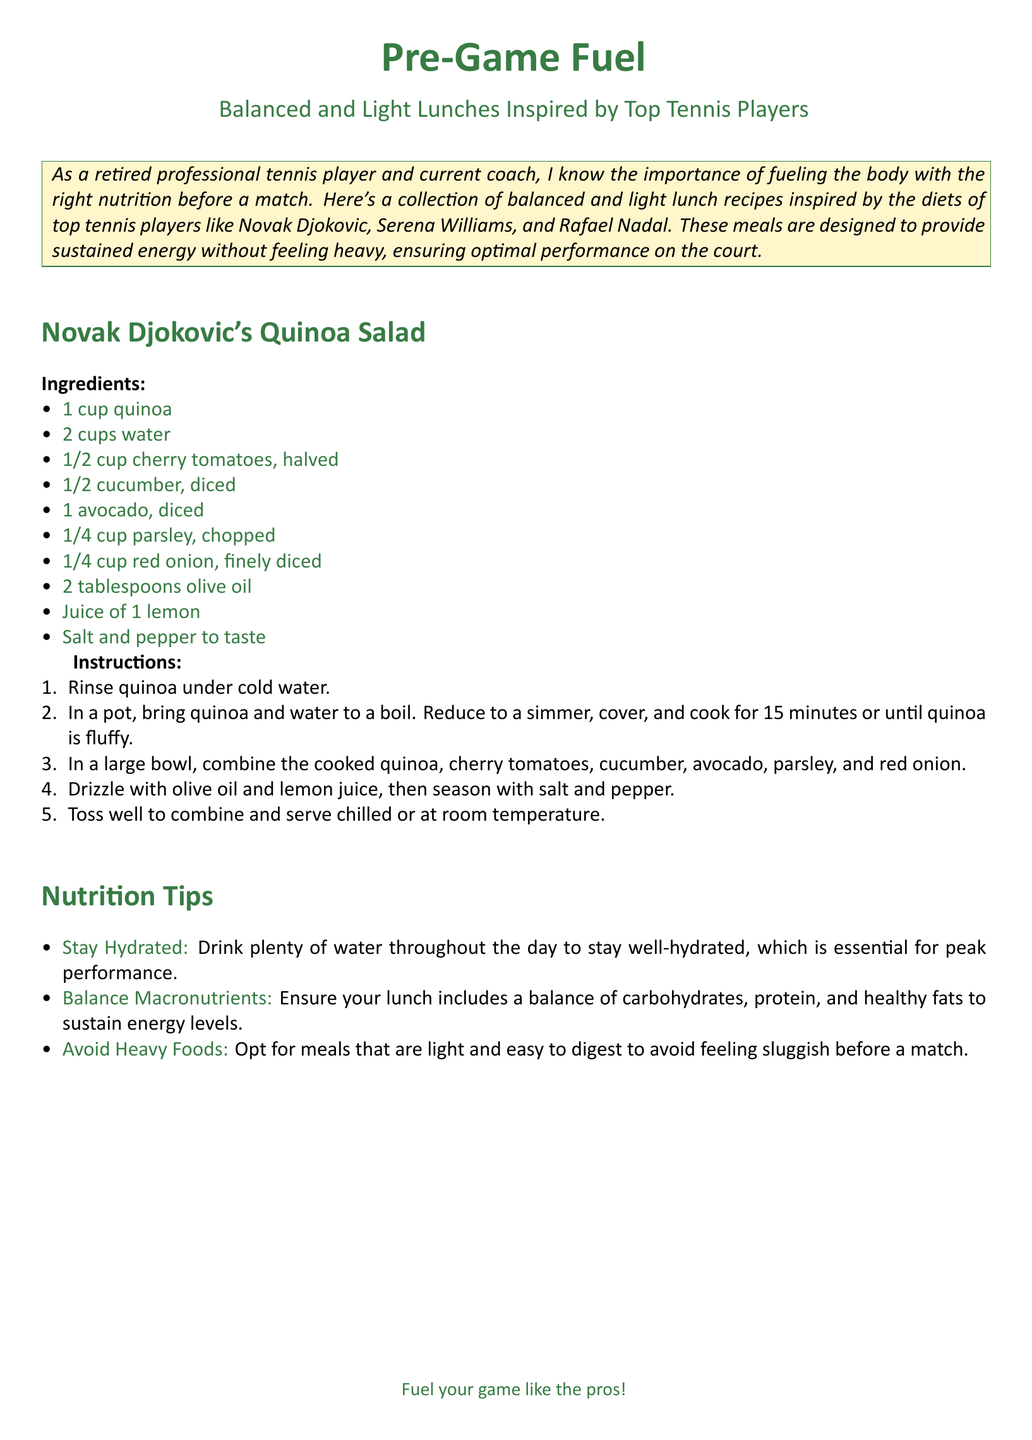What is the title of the document? The title of the document is centered at the top and states "Pre-Game Fuel".
Answer: Pre-Game Fuel Who is the inspiration behind the recipes? The text mentions that the recipes are inspired by top tennis players, including names like Novak Djokovic and Serena Williams.
Answer: Top tennis players How many cups of quinoa are needed for the salad? The ingredients list states that 1 cup of quinoa is required.
Answer: 1 cup What type of oil is used in the quinoa salad? The ingredients list includes 2 tablespoons of olive oil.
Answer: Olive oil What is the cooking time for the quinoa? The instructions specify that the quinoa should be cooked for 15 minutes.
Answer: 15 minutes What is a key nutrition tip mentioned in the document? The document provides several nutrition tips, one of which emphasizes staying hydrated.
Answer: Stay Hydrated How is the quinoa salad served? The instructions indicate that the salad can be served chilled or at room temperature.
Answer: Chilled or room temperature What is the main purpose of the document? The text introduces the collection of recipes as a way to fuel the body with proper nutrition before matches.
Answer: Fueling the body What is one of the ingredients in the salad besides quinoa? The ingredients list includes other components, such as cherry tomatoes or avocado.
Answer: Cherry tomatoes (or avocado) 